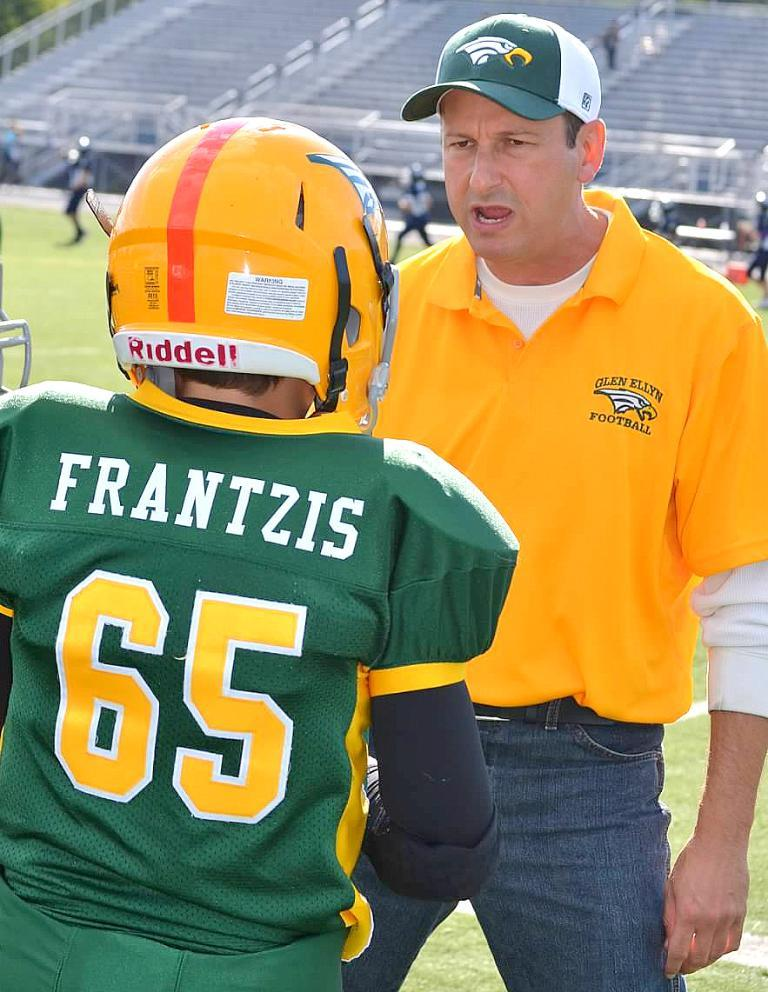How many people are standing in the image? There are two people standing opposite each other in the image. What are the other people in the image doing? There are additional people walking on the ground in the image. What can be seen in the background of the image? There are stairs visible in the background of the image. What type of instrument is being played by the person standing on the stairs in the image? There is no person standing on the stairs in the image, and no instrument is being played. 